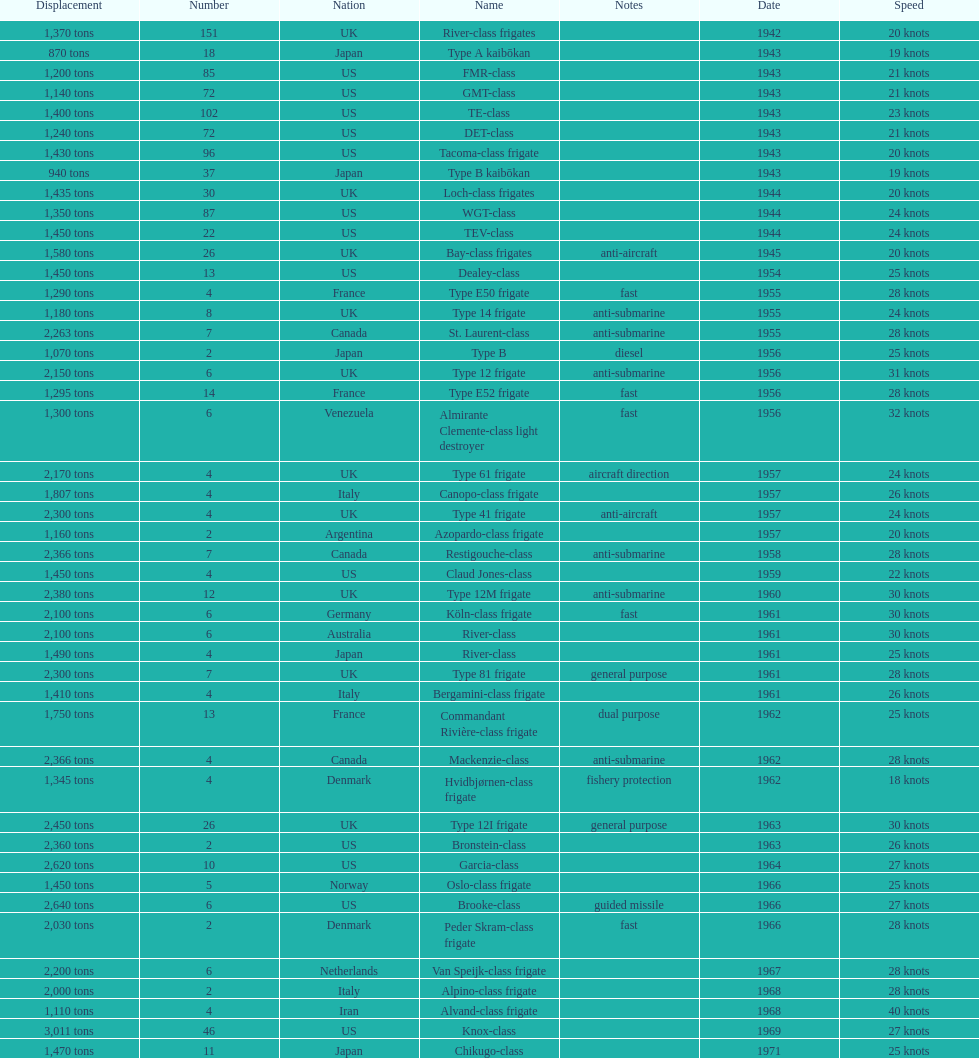How many tons of displacement does type b have? 940 tons. 